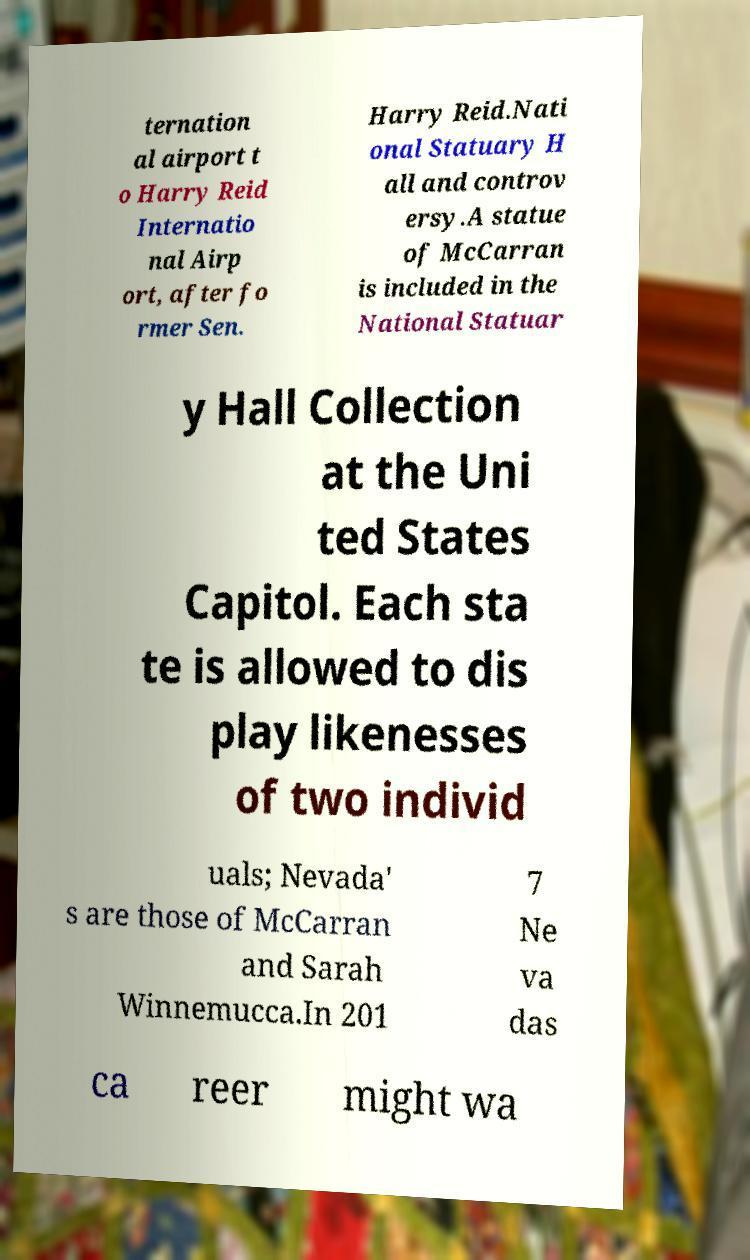There's text embedded in this image that I need extracted. Can you transcribe it verbatim? ternation al airport t o Harry Reid Internatio nal Airp ort, after fo rmer Sen. Harry Reid.Nati onal Statuary H all and controv ersy.A statue of McCarran is included in the National Statuar y Hall Collection at the Uni ted States Capitol. Each sta te is allowed to dis play likenesses of two individ uals; Nevada' s are those of McCarran and Sarah Winnemucca.In 201 7 Ne va das ca reer might wa 